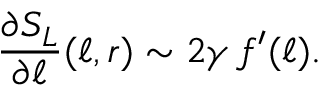<formula> <loc_0><loc_0><loc_500><loc_500>\frac { \partial S _ { L } } { \partial \ell } ( \ell , r ) \sim 2 \gamma \, f ^ { \prime } ( \ell ) .</formula> 